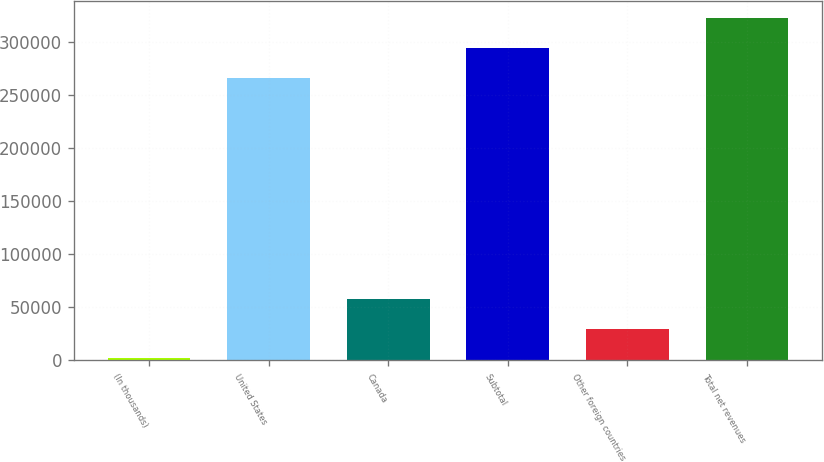Convert chart to OTSL. <chart><loc_0><loc_0><loc_500><loc_500><bar_chart><fcel>(In thousands)<fcel>United States<fcel>Canada<fcel>Subtotal<fcel>Other foreign countries<fcel>Total net revenues<nl><fcel>2005<fcel>266048<fcel>57814.6<fcel>293953<fcel>29909.8<fcel>321858<nl></chart> 